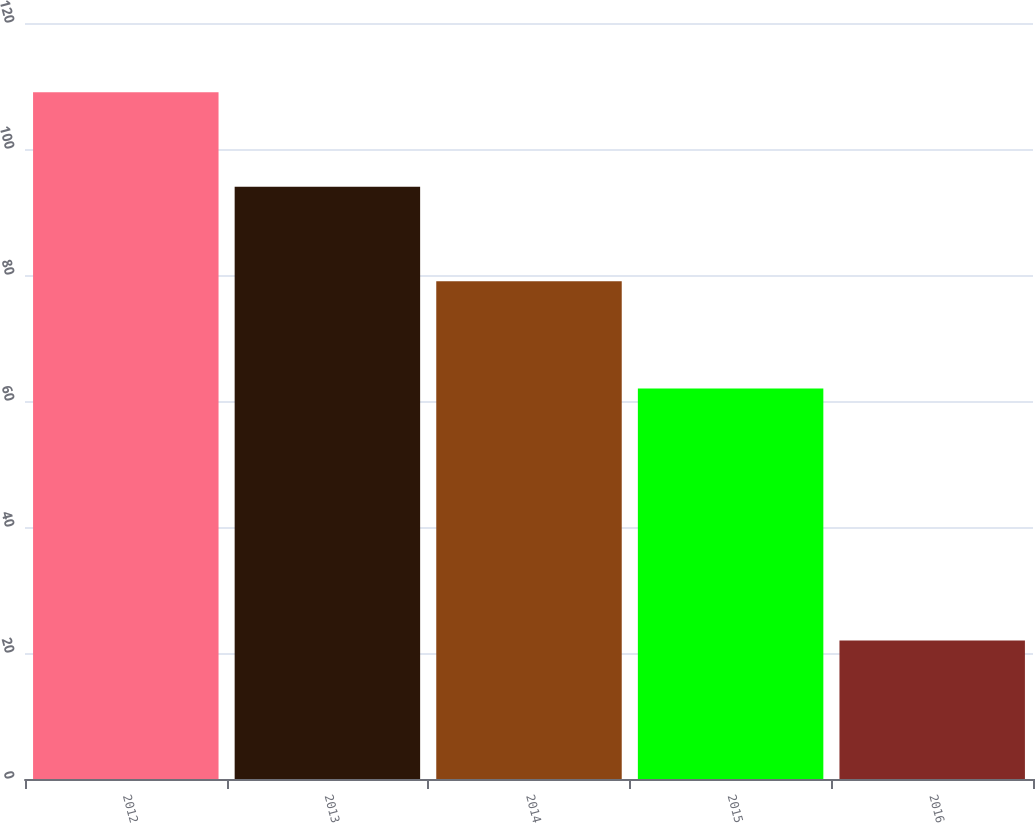Convert chart to OTSL. <chart><loc_0><loc_0><loc_500><loc_500><bar_chart><fcel>2012<fcel>2013<fcel>2014<fcel>2015<fcel>2016<nl><fcel>109<fcel>94<fcel>79<fcel>62<fcel>22<nl></chart> 